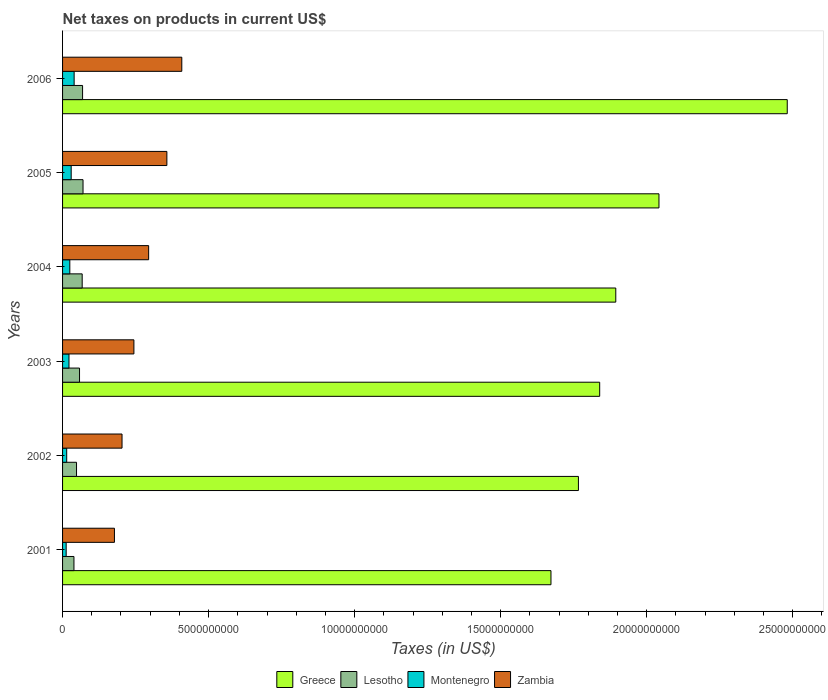How many different coloured bars are there?
Provide a short and direct response. 4. How many groups of bars are there?
Your answer should be compact. 6. In how many cases, is the number of bars for a given year not equal to the number of legend labels?
Provide a succinct answer. 0. What is the net taxes on products in Montenegro in 2001?
Provide a short and direct response. 1.23e+08. Across all years, what is the maximum net taxes on products in Lesotho?
Provide a succinct answer. 7.01e+08. Across all years, what is the minimum net taxes on products in Montenegro?
Keep it short and to the point. 1.23e+08. In which year was the net taxes on products in Zambia maximum?
Make the answer very short. 2006. What is the total net taxes on products in Zambia in the graph?
Provide a short and direct response. 1.69e+1. What is the difference between the net taxes on products in Greece in 2001 and that in 2004?
Your answer should be very brief. -2.22e+09. What is the difference between the net taxes on products in Zambia in 2001 and the net taxes on products in Greece in 2002?
Give a very brief answer. -1.59e+1. What is the average net taxes on products in Zambia per year?
Give a very brief answer. 2.81e+09. In the year 2004, what is the difference between the net taxes on products in Lesotho and net taxes on products in Montenegro?
Give a very brief answer. 4.24e+08. In how many years, is the net taxes on products in Greece greater than 18000000000 US$?
Your answer should be compact. 4. What is the ratio of the net taxes on products in Lesotho in 2002 to that in 2006?
Offer a very short reply. 0.7. Is the net taxes on products in Montenegro in 2005 less than that in 2006?
Your answer should be very brief. Yes. What is the difference between the highest and the second highest net taxes on products in Montenegro?
Offer a very short reply. 1.01e+08. What is the difference between the highest and the lowest net taxes on products in Zambia?
Provide a short and direct response. 2.31e+09. In how many years, is the net taxes on products in Lesotho greater than the average net taxes on products in Lesotho taken over all years?
Your answer should be very brief. 3. Is the sum of the net taxes on products in Zambia in 2005 and 2006 greater than the maximum net taxes on products in Greece across all years?
Provide a short and direct response. No. Is it the case that in every year, the sum of the net taxes on products in Greece and net taxes on products in Zambia is greater than the sum of net taxes on products in Montenegro and net taxes on products in Lesotho?
Your response must be concise. Yes. What does the 3rd bar from the top in 2006 represents?
Your response must be concise. Lesotho. What does the 4th bar from the bottom in 2004 represents?
Your answer should be compact. Zambia. Is it the case that in every year, the sum of the net taxes on products in Lesotho and net taxes on products in Montenegro is greater than the net taxes on products in Zambia?
Your response must be concise. No. Are all the bars in the graph horizontal?
Offer a terse response. Yes. How many years are there in the graph?
Make the answer very short. 6. What is the difference between two consecutive major ticks on the X-axis?
Ensure brevity in your answer.  5.00e+09. Does the graph contain any zero values?
Your answer should be very brief. No. How many legend labels are there?
Your answer should be very brief. 4. What is the title of the graph?
Your response must be concise. Net taxes on products in current US$. Does "European Union" appear as one of the legend labels in the graph?
Offer a terse response. No. What is the label or title of the X-axis?
Offer a terse response. Taxes (in US$). What is the Taxes (in US$) in Greece in 2001?
Offer a terse response. 1.67e+1. What is the Taxes (in US$) in Lesotho in 2001?
Give a very brief answer. 3.90e+08. What is the Taxes (in US$) of Montenegro in 2001?
Your answer should be compact. 1.23e+08. What is the Taxes (in US$) in Zambia in 2001?
Provide a succinct answer. 1.78e+09. What is the Taxes (in US$) in Greece in 2002?
Your answer should be compact. 1.77e+1. What is the Taxes (in US$) of Lesotho in 2002?
Make the answer very short. 4.78e+08. What is the Taxes (in US$) of Montenegro in 2002?
Give a very brief answer. 1.41e+08. What is the Taxes (in US$) of Zambia in 2002?
Keep it short and to the point. 2.04e+09. What is the Taxes (in US$) of Greece in 2003?
Your answer should be very brief. 1.84e+1. What is the Taxes (in US$) of Lesotho in 2003?
Make the answer very short. 5.81e+08. What is the Taxes (in US$) in Montenegro in 2003?
Offer a terse response. 2.20e+08. What is the Taxes (in US$) in Zambia in 2003?
Give a very brief answer. 2.44e+09. What is the Taxes (in US$) in Greece in 2004?
Offer a terse response. 1.89e+1. What is the Taxes (in US$) of Lesotho in 2004?
Make the answer very short. 6.72e+08. What is the Taxes (in US$) of Montenegro in 2004?
Make the answer very short. 2.48e+08. What is the Taxes (in US$) of Zambia in 2004?
Your answer should be compact. 2.95e+09. What is the Taxes (in US$) in Greece in 2005?
Provide a short and direct response. 2.04e+1. What is the Taxes (in US$) of Lesotho in 2005?
Offer a very short reply. 7.01e+08. What is the Taxes (in US$) in Montenegro in 2005?
Offer a very short reply. 2.95e+08. What is the Taxes (in US$) in Zambia in 2005?
Make the answer very short. 3.57e+09. What is the Taxes (in US$) in Greece in 2006?
Make the answer very short. 2.48e+1. What is the Taxes (in US$) in Lesotho in 2006?
Offer a terse response. 6.85e+08. What is the Taxes (in US$) in Montenegro in 2006?
Provide a succinct answer. 3.96e+08. What is the Taxes (in US$) in Zambia in 2006?
Ensure brevity in your answer.  4.08e+09. Across all years, what is the maximum Taxes (in US$) of Greece?
Provide a succinct answer. 2.48e+1. Across all years, what is the maximum Taxes (in US$) in Lesotho?
Ensure brevity in your answer.  7.01e+08. Across all years, what is the maximum Taxes (in US$) of Montenegro?
Your response must be concise. 3.96e+08. Across all years, what is the maximum Taxes (in US$) of Zambia?
Keep it short and to the point. 4.08e+09. Across all years, what is the minimum Taxes (in US$) in Greece?
Offer a terse response. 1.67e+1. Across all years, what is the minimum Taxes (in US$) in Lesotho?
Make the answer very short. 3.90e+08. Across all years, what is the minimum Taxes (in US$) of Montenegro?
Your response must be concise. 1.23e+08. Across all years, what is the minimum Taxes (in US$) of Zambia?
Make the answer very short. 1.78e+09. What is the total Taxes (in US$) in Greece in the graph?
Give a very brief answer. 1.17e+11. What is the total Taxes (in US$) of Lesotho in the graph?
Make the answer very short. 3.51e+09. What is the total Taxes (in US$) in Montenegro in the graph?
Your answer should be compact. 1.42e+09. What is the total Taxes (in US$) in Zambia in the graph?
Give a very brief answer. 1.69e+1. What is the difference between the Taxes (in US$) of Greece in 2001 and that in 2002?
Your answer should be compact. -9.40e+08. What is the difference between the Taxes (in US$) of Lesotho in 2001 and that in 2002?
Provide a succinct answer. -8.83e+07. What is the difference between the Taxes (in US$) in Montenegro in 2001 and that in 2002?
Ensure brevity in your answer.  -1.82e+07. What is the difference between the Taxes (in US$) in Zambia in 2001 and that in 2002?
Your answer should be compact. -2.60e+08. What is the difference between the Taxes (in US$) in Greece in 2001 and that in 2003?
Your answer should be very brief. -1.67e+09. What is the difference between the Taxes (in US$) of Lesotho in 2001 and that in 2003?
Provide a short and direct response. -1.91e+08. What is the difference between the Taxes (in US$) of Montenegro in 2001 and that in 2003?
Make the answer very short. -9.67e+07. What is the difference between the Taxes (in US$) of Zambia in 2001 and that in 2003?
Provide a succinct answer. -6.67e+08. What is the difference between the Taxes (in US$) of Greece in 2001 and that in 2004?
Give a very brief answer. -2.22e+09. What is the difference between the Taxes (in US$) in Lesotho in 2001 and that in 2004?
Your answer should be very brief. -2.82e+08. What is the difference between the Taxes (in US$) in Montenegro in 2001 and that in 2004?
Give a very brief answer. -1.25e+08. What is the difference between the Taxes (in US$) of Zambia in 2001 and that in 2004?
Offer a terse response. -1.17e+09. What is the difference between the Taxes (in US$) of Greece in 2001 and that in 2005?
Your answer should be very brief. -3.70e+09. What is the difference between the Taxes (in US$) of Lesotho in 2001 and that in 2005?
Your response must be concise. -3.11e+08. What is the difference between the Taxes (in US$) in Montenegro in 2001 and that in 2005?
Offer a terse response. -1.72e+08. What is the difference between the Taxes (in US$) of Zambia in 2001 and that in 2005?
Offer a terse response. -1.80e+09. What is the difference between the Taxes (in US$) of Greece in 2001 and that in 2006?
Keep it short and to the point. -8.09e+09. What is the difference between the Taxes (in US$) of Lesotho in 2001 and that in 2006?
Provide a short and direct response. -2.95e+08. What is the difference between the Taxes (in US$) of Montenegro in 2001 and that in 2006?
Give a very brief answer. -2.73e+08. What is the difference between the Taxes (in US$) of Zambia in 2001 and that in 2006?
Give a very brief answer. -2.31e+09. What is the difference between the Taxes (in US$) of Greece in 2002 and that in 2003?
Provide a short and direct response. -7.28e+08. What is the difference between the Taxes (in US$) of Lesotho in 2002 and that in 2003?
Provide a short and direct response. -1.03e+08. What is the difference between the Taxes (in US$) of Montenegro in 2002 and that in 2003?
Give a very brief answer. -7.85e+07. What is the difference between the Taxes (in US$) of Zambia in 2002 and that in 2003?
Offer a terse response. -4.06e+08. What is the difference between the Taxes (in US$) in Greece in 2002 and that in 2004?
Make the answer very short. -1.28e+09. What is the difference between the Taxes (in US$) of Lesotho in 2002 and that in 2004?
Provide a short and direct response. -1.94e+08. What is the difference between the Taxes (in US$) in Montenegro in 2002 and that in 2004?
Provide a short and direct response. -1.07e+08. What is the difference between the Taxes (in US$) of Zambia in 2002 and that in 2004?
Offer a terse response. -9.11e+08. What is the difference between the Taxes (in US$) of Greece in 2002 and that in 2005?
Provide a succinct answer. -2.76e+09. What is the difference between the Taxes (in US$) of Lesotho in 2002 and that in 2005?
Give a very brief answer. -2.23e+08. What is the difference between the Taxes (in US$) of Montenegro in 2002 and that in 2005?
Keep it short and to the point. -1.53e+08. What is the difference between the Taxes (in US$) in Zambia in 2002 and that in 2005?
Provide a short and direct response. -1.54e+09. What is the difference between the Taxes (in US$) in Greece in 2002 and that in 2006?
Provide a short and direct response. -7.15e+09. What is the difference between the Taxes (in US$) in Lesotho in 2002 and that in 2006?
Provide a short and direct response. -2.07e+08. What is the difference between the Taxes (in US$) of Montenegro in 2002 and that in 2006?
Offer a very short reply. -2.55e+08. What is the difference between the Taxes (in US$) of Zambia in 2002 and that in 2006?
Your answer should be compact. -2.05e+09. What is the difference between the Taxes (in US$) in Greece in 2003 and that in 2004?
Keep it short and to the point. -5.51e+08. What is the difference between the Taxes (in US$) of Lesotho in 2003 and that in 2004?
Ensure brevity in your answer.  -9.11e+07. What is the difference between the Taxes (in US$) of Montenegro in 2003 and that in 2004?
Provide a short and direct response. -2.83e+07. What is the difference between the Taxes (in US$) in Zambia in 2003 and that in 2004?
Your response must be concise. -5.05e+08. What is the difference between the Taxes (in US$) of Greece in 2003 and that in 2005?
Provide a short and direct response. -2.03e+09. What is the difference between the Taxes (in US$) in Lesotho in 2003 and that in 2005?
Your answer should be compact. -1.20e+08. What is the difference between the Taxes (in US$) in Montenegro in 2003 and that in 2005?
Offer a terse response. -7.50e+07. What is the difference between the Taxes (in US$) of Zambia in 2003 and that in 2005?
Offer a very short reply. -1.13e+09. What is the difference between the Taxes (in US$) in Greece in 2003 and that in 2006?
Offer a very short reply. -6.42e+09. What is the difference between the Taxes (in US$) of Lesotho in 2003 and that in 2006?
Offer a very short reply. -1.04e+08. What is the difference between the Taxes (in US$) in Montenegro in 2003 and that in 2006?
Offer a very short reply. -1.76e+08. What is the difference between the Taxes (in US$) of Zambia in 2003 and that in 2006?
Keep it short and to the point. -1.64e+09. What is the difference between the Taxes (in US$) of Greece in 2004 and that in 2005?
Offer a very short reply. -1.48e+09. What is the difference between the Taxes (in US$) of Lesotho in 2004 and that in 2005?
Make the answer very short. -2.91e+07. What is the difference between the Taxes (in US$) in Montenegro in 2004 and that in 2005?
Your answer should be very brief. -4.67e+07. What is the difference between the Taxes (in US$) in Zambia in 2004 and that in 2005?
Ensure brevity in your answer.  -6.25e+08. What is the difference between the Taxes (in US$) of Greece in 2004 and that in 2006?
Offer a very short reply. -5.87e+09. What is the difference between the Taxes (in US$) of Lesotho in 2004 and that in 2006?
Ensure brevity in your answer.  -1.31e+07. What is the difference between the Taxes (in US$) in Montenegro in 2004 and that in 2006?
Keep it short and to the point. -1.48e+08. What is the difference between the Taxes (in US$) in Zambia in 2004 and that in 2006?
Offer a terse response. -1.14e+09. What is the difference between the Taxes (in US$) in Greece in 2005 and that in 2006?
Provide a short and direct response. -4.39e+09. What is the difference between the Taxes (in US$) in Lesotho in 2005 and that in 2006?
Offer a very short reply. 1.60e+07. What is the difference between the Taxes (in US$) of Montenegro in 2005 and that in 2006?
Ensure brevity in your answer.  -1.01e+08. What is the difference between the Taxes (in US$) in Zambia in 2005 and that in 2006?
Make the answer very short. -5.11e+08. What is the difference between the Taxes (in US$) in Greece in 2001 and the Taxes (in US$) in Lesotho in 2002?
Give a very brief answer. 1.62e+1. What is the difference between the Taxes (in US$) of Greece in 2001 and the Taxes (in US$) of Montenegro in 2002?
Make the answer very short. 1.66e+1. What is the difference between the Taxes (in US$) of Greece in 2001 and the Taxes (in US$) of Zambia in 2002?
Provide a succinct answer. 1.47e+1. What is the difference between the Taxes (in US$) of Lesotho in 2001 and the Taxes (in US$) of Montenegro in 2002?
Give a very brief answer. 2.48e+08. What is the difference between the Taxes (in US$) in Lesotho in 2001 and the Taxes (in US$) in Zambia in 2002?
Ensure brevity in your answer.  -1.65e+09. What is the difference between the Taxes (in US$) in Montenegro in 2001 and the Taxes (in US$) in Zambia in 2002?
Offer a terse response. -1.91e+09. What is the difference between the Taxes (in US$) of Greece in 2001 and the Taxes (in US$) of Lesotho in 2003?
Provide a short and direct response. 1.61e+1. What is the difference between the Taxes (in US$) of Greece in 2001 and the Taxes (in US$) of Montenegro in 2003?
Make the answer very short. 1.65e+1. What is the difference between the Taxes (in US$) of Greece in 2001 and the Taxes (in US$) of Zambia in 2003?
Your response must be concise. 1.43e+1. What is the difference between the Taxes (in US$) of Lesotho in 2001 and the Taxes (in US$) of Montenegro in 2003?
Offer a very short reply. 1.70e+08. What is the difference between the Taxes (in US$) of Lesotho in 2001 and the Taxes (in US$) of Zambia in 2003?
Give a very brief answer. -2.05e+09. What is the difference between the Taxes (in US$) of Montenegro in 2001 and the Taxes (in US$) of Zambia in 2003?
Keep it short and to the point. -2.32e+09. What is the difference between the Taxes (in US$) of Greece in 2001 and the Taxes (in US$) of Lesotho in 2004?
Your answer should be compact. 1.61e+1. What is the difference between the Taxes (in US$) in Greece in 2001 and the Taxes (in US$) in Montenegro in 2004?
Your answer should be compact. 1.65e+1. What is the difference between the Taxes (in US$) in Greece in 2001 and the Taxes (in US$) in Zambia in 2004?
Your response must be concise. 1.38e+1. What is the difference between the Taxes (in US$) in Lesotho in 2001 and the Taxes (in US$) in Montenegro in 2004?
Ensure brevity in your answer.  1.42e+08. What is the difference between the Taxes (in US$) in Lesotho in 2001 and the Taxes (in US$) in Zambia in 2004?
Your response must be concise. -2.56e+09. What is the difference between the Taxes (in US$) in Montenegro in 2001 and the Taxes (in US$) in Zambia in 2004?
Your answer should be compact. -2.82e+09. What is the difference between the Taxes (in US$) in Greece in 2001 and the Taxes (in US$) in Lesotho in 2005?
Provide a short and direct response. 1.60e+1. What is the difference between the Taxes (in US$) in Greece in 2001 and the Taxes (in US$) in Montenegro in 2005?
Provide a short and direct response. 1.64e+1. What is the difference between the Taxes (in US$) of Greece in 2001 and the Taxes (in US$) of Zambia in 2005?
Ensure brevity in your answer.  1.32e+1. What is the difference between the Taxes (in US$) in Lesotho in 2001 and the Taxes (in US$) in Montenegro in 2005?
Give a very brief answer. 9.48e+07. What is the difference between the Taxes (in US$) of Lesotho in 2001 and the Taxes (in US$) of Zambia in 2005?
Provide a succinct answer. -3.18e+09. What is the difference between the Taxes (in US$) in Montenegro in 2001 and the Taxes (in US$) in Zambia in 2005?
Your response must be concise. -3.45e+09. What is the difference between the Taxes (in US$) of Greece in 2001 and the Taxes (in US$) of Lesotho in 2006?
Give a very brief answer. 1.60e+1. What is the difference between the Taxes (in US$) in Greece in 2001 and the Taxes (in US$) in Montenegro in 2006?
Your response must be concise. 1.63e+1. What is the difference between the Taxes (in US$) of Greece in 2001 and the Taxes (in US$) of Zambia in 2006?
Provide a succinct answer. 1.26e+1. What is the difference between the Taxes (in US$) of Lesotho in 2001 and the Taxes (in US$) of Montenegro in 2006?
Provide a short and direct response. -6.37e+06. What is the difference between the Taxes (in US$) in Lesotho in 2001 and the Taxes (in US$) in Zambia in 2006?
Your response must be concise. -3.69e+09. What is the difference between the Taxes (in US$) of Montenegro in 2001 and the Taxes (in US$) of Zambia in 2006?
Provide a succinct answer. -3.96e+09. What is the difference between the Taxes (in US$) in Greece in 2002 and the Taxes (in US$) in Lesotho in 2003?
Keep it short and to the point. 1.71e+1. What is the difference between the Taxes (in US$) in Greece in 2002 and the Taxes (in US$) in Montenegro in 2003?
Give a very brief answer. 1.74e+1. What is the difference between the Taxes (in US$) of Greece in 2002 and the Taxes (in US$) of Zambia in 2003?
Give a very brief answer. 1.52e+1. What is the difference between the Taxes (in US$) in Lesotho in 2002 and the Taxes (in US$) in Montenegro in 2003?
Your answer should be very brief. 2.58e+08. What is the difference between the Taxes (in US$) of Lesotho in 2002 and the Taxes (in US$) of Zambia in 2003?
Your response must be concise. -1.96e+09. What is the difference between the Taxes (in US$) of Montenegro in 2002 and the Taxes (in US$) of Zambia in 2003?
Your answer should be compact. -2.30e+09. What is the difference between the Taxes (in US$) of Greece in 2002 and the Taxes (in US$) of Lesotho in 2004?
Provide a succinct answer. 1.70e+1. What is the difference between the Taxes (in US$) of Greece in 2002 and the Taxes (in US$) of Montenegro in 2004?
Ensure brevity in your answer.  1.74e+1. What is the difference between the Taxes (in US$) in Greece in 2002 and the Taxes (in US$) in Zambia in 2004?
Your response must be concise. 1.47e+1. What is the difference between the Taxes (in US$) of Lesotho in 2002 and the Taxes (in US$) of Montenegro in 2004?
Offer a terse response. 2.30e+08. What is the difference between the Taxes (in US$) of Lesotho in 2002 and the Taxes (in US$) of Zambia in 2004?
Your answer should be compact. -2.47e+09. What is the difference between the Taxes (in US$) in Montenegro in 2002 and the Taxes (in US$) in Zambia in 2004?
Your answer should be compact. -2.81e+09. What is the difference between the Taxes (in US$) of Greece in 2002 and the Taxes (in US$) of Lesotho in 2005?
Make the answer very short. 1.70e+1. What is the difference between the Taxes (in US$) of Greece in 2002 and the Taxes (in US$) of Montenegro in 2005?
Make the answer very short. 1.74e+1. What is the difference between the Taxes (in US$) in Greece in 2002 and the Taxes (in US$) in Zambia in 2005?
Give a very brief answer. 1.41e+1. What is the difference between the Taxes (in US$) of Lesotho in 2002 and the Taxes (in US$) of Montenegro in 2005?
Make the answer very short. 1.83e+08. What is the difference between the Taxes (in US$) of Lesotho in 2002 and the Taxes (in US$) of Zambia in 2005?
Provide a succinct answer. -3.09e+09. What is the difference between the Taxes (in US$) of Montenegro in 2002 and the Taxes (in US$) of Zambia in 2005?
Your response must be concise. -3.43e+09. What is the difference between the Taxes (in US$) of Greece in 2002 and the Taxes (in US$) of Lesotho in 2006?
Give a very brief answer. 1.70e+1. What is the difference between the Taxes (in US$) in Greece in 2002 and the Taxes (in US$) in Montenegro in 2006?
Offer a very short reply. 1.73e+1. What is the difference between the Taxes (in US$) in Greece in 2002 and the Taxes (in US$) in Zambia in 2006?
Your answer should be very brief. 1.36e+1. What is the difference between the Taxes (in US$) in Lesotho in 2002 and the Taxes (in US$) in Montenegro in 2006?
Offer a very short reply. 8.20e+07. What is the difference between the Taxes (in US$) in Lesotho in 2002 and the Taxes (in US$) in Zambia in 2006?
Offer a terse response. -3.60e+09. What is the difference between the Taxes (in US$) of Montenegro in 2002 and the Taxes (in US$) of Zambia in 2006?
Your response must be concise. -3.94e+09. What is the difference between the Taxes (in US$) in Greece in 2003 and the Taxes (in US$) in Lesotho in 2004?
Offer a very short reply. 1.77e+1. What is the difference between the Taxes (in US$) in Greece in 2003 and the Taxes (in US$) in Montenegro in 2004?
Ensure brevity in your answer.  1.81e+1. What is the difference between the Taxes (in US$) of Greece in 2003 and the Taxes (in US$) of Zambia in 2004?
Your answer should be very brief. 1.54e+1. What is the difference between the Taxes (in US$) in Lesotho in 2003 and the Taxes (in US$) in Montenegro in 2004?
Offer a terse response. 3.32e+08. What is the difference between the Taxes (in US$) of Lesotho in 2003 and the Taxes (in US$) of Zambia in 2004?
Your answer should be compact. -2.37e+09. What is the difference between the Taxes (in US$) in Montenegro in 2003 and the Taxes (in US$) in Zambia in 2004?
Your answer should be very brief. -2.73e+09. What is the difference between the Taxes (in US$) in Greece in 2003 and the Taxes (in US$) in Lesotho in 2005?
Provide a short and direct response. 1.77e+1. What is the difference between the Taxes (in US$) of Greece in 2003 and the Taxes (in US$) of Montenegro in 2005?
Your answer should be very brief. 1.81e+1. What is the difference between the Taxes (in US$) in Greece in 2003 and the Taxes (in US$) in Zambia in 2005?
Offer a very short reply. 1.48e+1. What is the difference between the Taxes (in US$) in Lesotho in 2003 and the Taxes (in US$) in Montenegro in 2005?
Provide a short and direct response. 2.86e+08. What is the difference between the Taxes (in US$) in Lesotho in 2003 and the Taxes (in US$) in Zambia in 2005?
Keep it short and to the point. -2.99e+09. What is the difference between the Taxes (in US$) in Montenegro in 2003 and the Taxes (in US$) in Zambia in 2005?
Your answer should be compact. -3.35e+09. What is the difference between the Taxes (in US$) of Greece in 2003 and the Taxes (in US$) of Lesotho in 2006?
Offer a terse response. 1.77e+1. What is the difference between the Taxes (in US$) in Greece in 2003 and the Taxes (in US$) in Montenegro in 2006?
Keep it short and to the point. 1.80e+1. What is the difference between the Taxes (in US$) of Greece in 2003 and the Taxes (in US$) of Zambia in 2006?
Keep it short and to the point. 1.43e+1. What is the difference between the Taxes (in US$) in Lesotho in 2003 and the Taxes (in US$) in Montenegro in 2006?
Provide a succinct answer. 1.85e+08. What is the difference between the Taxes (in US$) of Lesotho in 2003 and the Taxes (in US$) of Zambia in 2006?
Provide a succinct answer. -3.50e+09. What is the difference between the Taxes (in US$) of Montenegro in 2003 and the Taxes (in US$) of Zambia in 2006?
Offer a terse response. -3.86e+09. What is the difference between the Taxes (in US$) in Greece in 2004 and the Taxes (in US$) in Lesotho in 2005?
Give a very brief answer. 1.82e+1. What is the difference between the Taxes (in US$) in Greece in 2004 and the Taxes (in US$) in Montenegro in 2005?
Offer a terse response. 1.86e+1. What is the difference between the Taxes (in US$) in Greece in 2004 and the Taxes (in US$) in Zambia in 2005?
Make the answer very short. 1.54e+1. What is the difference between the Taxes (in US$) in Lesotho in 2004 and the Taxes (in US$) in Montenegro in 2005?
Your answer should be very brief. 3.77e+08. What is the difference between the Taxes (in US$) of Lesotho in 2004 and the Taxes (in US$) of Zambia in 2005?
Give a very brief answer. -2.90e+09. What is the difference between the Taxes (in US$) of Montenegro in 2004 and the Taxes (in US$) of Zambia in 2005?
Your response must be concise. -3.32e+09. What is the difference between the Taxes (in US$) of Greece in 2004 and the Taxes (in US$) of Lesotho in 2006?
Give a very brief answer. 1.83e+1. What is the difference between the Taxes (in US$) in Greece in 2004 and the Taxes (in US$) in Montenegro in 2006?
Give a very brief answer. 1.85e+1. What is the difference between the Taxes (in US$) of Greece in 2004 and the Taxes (in US$) of Zambia in 2006?
Make the answer very short. 1.49e+1. What is the difference between the Taxes (in US$) in Lesotho in 2004 and the Taxes (in US$) in Montenegro in 2006?
Your answer should be very brief. 2.76e+08. What is the difference between the Taxes (in US$) of Lesotho in 2004 and the Taxes (in US$) of Zambia in 2006?
Your response must be concise. -3.41e+09. What is the difference between the Taxes (in US$) in Montenegro in 2004 and the Taxes (in US$) in Zambia in 2006?
Offer a terse response. -3.83e+09. What is the difference between the Taxes (in US$) of Greece in 2005 and the Taxes (in US$) of Lesotho in 2006?
Offer a terse response. 1.97e+1. What is the difference between the Taxes (in US$) in Greece in 2005 and the Taxes (in US$) in Montenegro in 2006?
Your answer should be compact. 2.00e+1. What is the difference between the Taxes (in US$) in Greece in 2005 and the Taxes (in US$) in Zambia in 2006?
Provide a short and direct response. 1.63e+1. What is the difference between the Taxes (in US$) of Lesotho in 2005 and the Taxes (in US$) of Montenegro in 2006?
Keep it short and to the point. 3.05e+08. What is the difference between the Taxes (in US$) in Lesotho in 2005 and the Taxes (in US$) in Zambia in 2006?
Your answer should be compact. -3.38e+09. What is the difference between the Taxes (in US$) in Montenegro in 2005 and the Taxes (in US$) in Zambia in 2006?
Provide a succinct answer. -3.79e+09. What is the average Taxes (in US$) in Greece per year?
Provide a succinct answer. 1.95e+1. What is the average Taxes (in US$) of Lesotho per year?
Your answer should be very brief. 5.84e+08. What is the average Taxes (in US$) in Montenegro per year?
Provide a short and direct response. 2.37e+08. What is the average Taxes (in US$) of Zambia per year?
Provide a short and direct response. 2.81e+09. In the year 2001, what is the difference between the Taxes (in US$) in Greece and Taxes (in US$) in Lesotho?
Your answer should be very brief. 1.63e+1. In the year 2001, what is the difference between the Taxes (in US$) of Greece and Taxes (in US$) of Montenegro?
Your answer should be compact. 1.66e+1. In the year 2001, what is the difference between the Taxes (in US$) of Greece and Taxes (in US$) of Zambia?
Offer a very short reply. 1.49e+1. In the year 2001, what is the difference between the Taxes (in US$) in Lesotho and Taxes (in US$) in Montenegro?
Give a very brief answer. 2.67e+08. In the year 2001, what is the difference between the Taxes (in US$) of Lesotho and Taxes (in US$) of Zambia?
Keep it short and to the point. -1.39e+09. In the year 2001, what is the difference between the Taxes (in US$) of Montenegro and Taxes (in US$) of Zambia?
Your answer should be compact. -1.65e+09. In the year 2002, what is the difference between the Taxes (in US$) in Greece and Taxes (in US$) in Lesotho?
Give a very brief answer. 1.72e+1. In the year 2002, what is the difference between the Taxes (in US$) in Greece and Taxes (in US$) in Montenegro?
Keep it short and to the point. 1.75e+1. In the year 2002, what is the difference between the Taxes (in US$) of Greece and Taxes (in US$) of Zambia?
Keep it short and to the point. 1.56e+1. In the year 2002, what is the difference between the Taxes (in US$) in Lesotho and Taxes (in US$) in Montenegro?
Provide a short and direct response. 3.37e+08. In the year 2002, what is the difference between the Taxes (in US$) of Lesotho and Taxes (in US$) of Zambia?
Provide a succinct answer. -1.56e+09. In the year 2002, what is the difference between the Taxes (in US$) of Montenegro and Taxes (in US$) of Zambia?
Ensure brevity in your answer.  -1.89e+09. In the year 2003, what is the difference between the Taxes (in US$) in Greece and Taxes (in US$) in Lesotho?
Offer a very short reply. 1.78e+1. In the year 2003, what is the difference between the Taxes (in US$) in Greece and Taxes (in US$) in Montenegro?
Your answer should be compact. 1.82e+1. In the year 2003, what is the difference between the Taxes (in US$) of Greece and Taxes (in US$) of Zambia?
Provide a succinct answer. 1.59e+1. In the year 2003, what is the difference between the Taxes (in US$) in Lesotho and Taxes (in US$) in Montenegro?
Give a very brief answer. 3.61e+08. In the year 2003, what is the difference between the Taxes (in US$) in Lesotho and Taxes (in US$) in Zambia?
Give a very brief answer. -1.86e+09. In the year 2003, what is the difference between the Taxes (in US$) in Montenegro and Taxes (in US$) in Zambia?
Provide a short and direct response. -2.22e+09. In the year 2004, what is the difference between the Taxes (in US$) of Greece and Taxes (in US$) of Lesotho?
Give a very brief answer. 1.83e+1. In the year 2004, what is the difference between the Taxes (in US$) in Greece and Taxes (in US$) in Montenegro?
Offer a very short reply. 1.87e+1. In the year 2004, what is the difference between the Taxes (in US$) of Greece and Taxes (in US$) of Zambia?
Make the answer very short. 1.60e+1. In the year 2004, what is the difference between the Taxes (in US$) in Lesotho and Taxes (in US$) in Montenegro?
Your answer should be compact. 4.24e+08. In the year 2004, what is the difference between the Taxes (in US$) of Lesotho and Taxes (in US$) of Zambia?
Give a very brief answer. -2.28e+09. In the year 2004, what is the difference between the Taxes (in US$) in Montenegro and Taxes (in US$) in Zambia?
Keep it short and to the point. -2.70e+09. In the year 2005, what is the difference between the Taxes (in US$) of Greece and Taxes (in US$) of Lesotho?
Offer a very short reply. 1.97e+1. In the year 2005, what is the difference between the Taxes (in US$) in Greece and Taxes (in US$) in Montenegro?
Keep it short and to the point. 2.01e+1. In the year 2005, what is the difference between the Taxes (in US$) in Greece and Taxes (in US$) in Zambia?
Give a very brief answer. 1.69e+1. In the year 2005, what is the difference between the Taxes (in US$) in Lesotho and Taxes (in US$) in Montenegro?
Your answer should be very brief. 4.06e+08. In the year 2005, what is the difference between the Taxes (in US$) of Lesotho and Taxes (in US$) of Zambia?
Your answer should be compact. -2.87e+09. In the year 2005, what is the difference between the Taxes (in US$) in Montenegro and Taxes (in US$) in Zambia?
Provide a succinct answer. -3.28e+09. In the year 2006, what is the difference between the Taxes (in US$) in Greece and Taxes (in US$) in Lesotho?
Your answer should be very brief. 2.41e+1. In the year 2006, what is the difference between the Taxes (in US$) of Greece and Taxes (in US$) of Montenegro?
Your response must be concise. 2.44e+1. In the year 2006, what is the difference between the Taxes (in US$) of Greece and Taxes (in US$) of Zambia?
Your answer should be compact. 2.07e+1. In the year 2006, what is the difference between the Taxes (in US$) of Lesotho and Taxes (in US$) of Montenegro?
Your answer should be compact. 2.89e+08. In the year 2006, what is the difference between the Taxes (in US$) of Lesotho and Taxes (in US$) of Zambia?
Your answer should be very brief. -3.40e+09. In the year 2006, what is the difference between the Taxes (in US$) of Montenegro and Taxes (in US$) of Zambia?
Provide a succinct answer. -3.69e+09. What is the ratio of the Taxes (in US$) of Greece in 2001 to that in 2002?
Ensure brevity in your answer.  0.95. What is the ratio of the Taxes (in US$) of Lesotho in 2001 to that in 2002?
Your answer should be very brief. 0.82. What is the ratio of the Taxes (in US$) of Montenegro in 2001 to that in 2002?
Offer a terse response. 0.87. What is the ratio of the Taxes (in US$) in Zambia in 2001 to that in 2002?
Your answer should be compact. 0.87. What is the ratio of the Taxes (in US$) of Greece in 2001 to that in 2003?
Your answer should be very brief. 0.91. What is the ratio of the Taxes (in US$) in Lesotho in 2001 to that in 2003?
Keep it short and to the point. 0.67. What is the ratio of the Taxes (in US$) of Montenegro in 2001 to that in 2003?
Your response must be concise. 0.56. What is the ratio of the Taxes (in US$) of Zambia in 2001 to that in 2003?
Give a very brief answer. 0.73. What is the ratio of the Taxes (in US$) in Greece in 2001 to that in 2004?
Your answer should be very brief. 0.88. What is the ratio of the Taxes (in US$) in Lesotho in 2001 to that in 2004?
Your answer should be compact. 0.58. What is the ratio of the Taxes (in US$) of Montenegro in 2001 to that in 2004?
Ensure brevity in your answer.  0.5. What is the ratio of the Taxes (in US$) of Zambia in 2001 to that in 2004?
Give a very brief answer. 0.6. What is the ratio of the Taxes (in US$) in Greece in 2001 to that in 2005?
Offer a very short reply. 0.82. What is the ratio of the Taxes (in US$) in Lesotho in 2001 to that in 2005?
Keep it short and to the point. 0.56. What is the ratio of the Taxes (in US$) of Montenegro in 2001 to that in 2005?
Your answer should be compact. 0.42. What is the ratio of the Taxes (in US$) in Zambia in 2001 to that in 2005?
Provide a succinct answer. 0.5. What is the ratio of the Taxes (in US$) in Greece in 2001 to that in 2006?
Your response must be concise. 0.67. What is the ratio of the Taxes (in US$) of Lesotho in 2001 to that in 2006?
Ensure brevity in your answer.  0.57. What is the ratio of the Taxes (in US$) of Montenegro in 2001 to that in 2006?
Your response must be concise. 0.31. What is the ratio of the Taxes (in US$) in Zambia in 2001 to that in 2006?
Keep it short and to the point. 0.43. What is the ratio of the Taxes (in US$) of Greece in 2002 to that in 2003?
Give a very brief answer. 0.96. What is the ratio of the Taxes (in US$) of Lesotho in 2002 to that in 2003?
Your response must be concise. 0.82. What is the ratio of the Taxes (in US$) in Montenegro in 2002 to that in 2003?
Make the answer very short. 0.64. What is the ratio of the Taxes (in US$) of Zambia in 2002 to that in 2003?
Provide a succinct answer. 0.83. What is the ratio of the Taxes (in US$) of Greece in 2002 to that in 2004?
Ensure brevity in your answer.  0.93. What is the ratio of the Taxes (in US$) of Lesotho in 2002 to that in 2004?
Provide a succinct answer. 0.71. What is the ratio of the Taxes (in US$) of Montenegro in 2002 to that in 2004?
Provide a succinct answer. 0.57. What is the ratio of the Taxes (in US$) of Zambia in 2002 to that in 2004?
Your answer should be compact. 0.69. What is the ratio of the Taxes (in US$) of Greece in 2002 to that in 2005?
Offer a very short reply. 0.86. What is the ratio of the Taxes (in US$) of Lesotho in 2002 to that in 2005?
Give a very brief answer. 0.68. What is the ratio of the Taxes (in US$) in Montenegro in 2002 to that in 2005?
Make the answer very short. 0.48. What is the ratio of the Taxes (in US$) of Zambia in 2002 to that in 2005?
Provide a succinct answer. 0.57. What is the ratio of the Taxes (in US$) in Greece in 2002 to that in 2006?
Your answer should be very brief. 0.71. What is the ratio of the Taxes (in US$) of Lesotho in 2002 to that in 2006?
Your answer should be very brief. 0.7. What is the ratio of the Taxes (in US$) of Montenegro in 2002 to that in 2006?
Your answer should be compact. 0.36. What is the ratio of the Taxes (in US$) in Zambia in 2002 to that in 2006?
Make the answer very short. 0.5. What is the ratio of the Taxes (in US$) of Greece in 2003 to that in 2004?
Your response must be concise. 0.97. What is the ratio of the Taxes (in US$) of Lesotho in 2003 to that in 2004?
Offer a terse response. 0.86. What is the ratio of the Taxes (in US$) of Montenegro in 2003 to that in 2004?
Ensure brevity in your answer.  0.89. What is the ratio of the Taxes (in US$) of Zambia in 2003 to that in 2004?
Offer a terse response. 0.83. What is the ratio of the Taxes (in US$) of Greece in 2003 to that in 2005?
Your response must be concise. 0.9. What is the ratio of the Taxes (in US$) in Lesotho in 2003 to that in 2005?
Ensure brevity in your answer.  0.83. What is the ratio of the Taxes (in US$) of Montenegro in 2003 to that in 2005?
Ensure brevity in your answer.  0.75. What is the ratio of the Taxes (in US$) of Zambia in 2003 to that in 2005?
Ensure brevity in your answer.  0.68. What is the ratio of the Taxes (in US$) of Greece in 2003 to that in 2006?
Your answer should be compact. 0.74. What is the ratio of the Taxes (in US$) of Lesotho in 2003 to that in 2006?
Give a very brief answer. 0.85. What is the ratio of the Taxes (in US$) of Montenegro in 2003 to that in 2006?
Offer a very short reply. 0.56. What is the ratio of the Taxes (in US$) of Zambia in 2003 to that in 2006?
Keep it short and to the point. 0.6. What is the ratio of the Taxes (in US$) of Greece in 2004 to that in 2005?
Provide a succinct answer. 0.93. What is the ratio of the Taxes (in US$) of Lesotho in 2004 to that in 2005?
Your answer should be compact. 0.96. What is the ratio of the Taxes (in US$) of Montenegro in 2004 to that in 2005?
Provide a short and direct response. 0.84. What is the ratio of the Taxes (in US$) in Zambia in 2004 to that in 2005?
Your answer should be compact. 0.83. What is the ratio of the Taxes (in US$) of Greece in 2004 to that in 2006?
Provide a succinct answer. 0.76. What is the ratio of the Taxes (in US$) of Lesotho in 2004 to that in 2006?
Give a very brief answer. 0.98. What is the ratio of the Taxes (in US$) of Montenegro in 2004 to that in 2006?
Your response must be concise. 0.63. What is the ratio of the Taxes (in US$) in Zambia in 2004 to that in 2006?
Provide a short and direct response. 0.72. What is the ratio of the Taxes (in US$) in Greece in 2005 to that in 2006?
Keep it short and to the point. 0.82. What is the ratio of the Taxes (in US$) of Lesotho in 2005 to that in 2006?
Your answer should be very brief. 1.02. What is the ratio of the Taxes (in US$) of Montenegro in 2005 to that in 2006?
Your answer should be compact. 0.74. What is the ratio of the Taxes (in US$) in Zambia in 2005 to that in 2006?
Provide a succinct answer. 0.87. What is the difference between the highest and the second highest Taxes (in US$) of Greece?
Offer a very short reply. 4.39e+09. What is the difference between the highest and the second highest Taxes (in US$) in Lesotho?
Give a very brief answer. 1.60e+07. What is the difference between the highest and the second highest Taxes (in US$) of Montenegro?
Ensure brevity in your answer.  1.01e+08. What is the difference between the highest and the second highest Taxes (in US$) of Zambia?
Offer a very short reply. 5.11e+08. What is the difference between the highest and the lowest Taxes (in US$) of Greece?
Make the answer very short. 8.09e+09. What is the difference between the highest and the lowest Taxes (in US$) in Lesotho?
Your response must be concise. 3.11e+08. What is the difference between the highest and the lowest Taxes (in US$) in Montenegro?
Your response must be concise. 2.73e+08. What is the difference between the highest and the lowest Taxes (in US$) of Zambia?
Your response must be concise. 2.31e+09. 